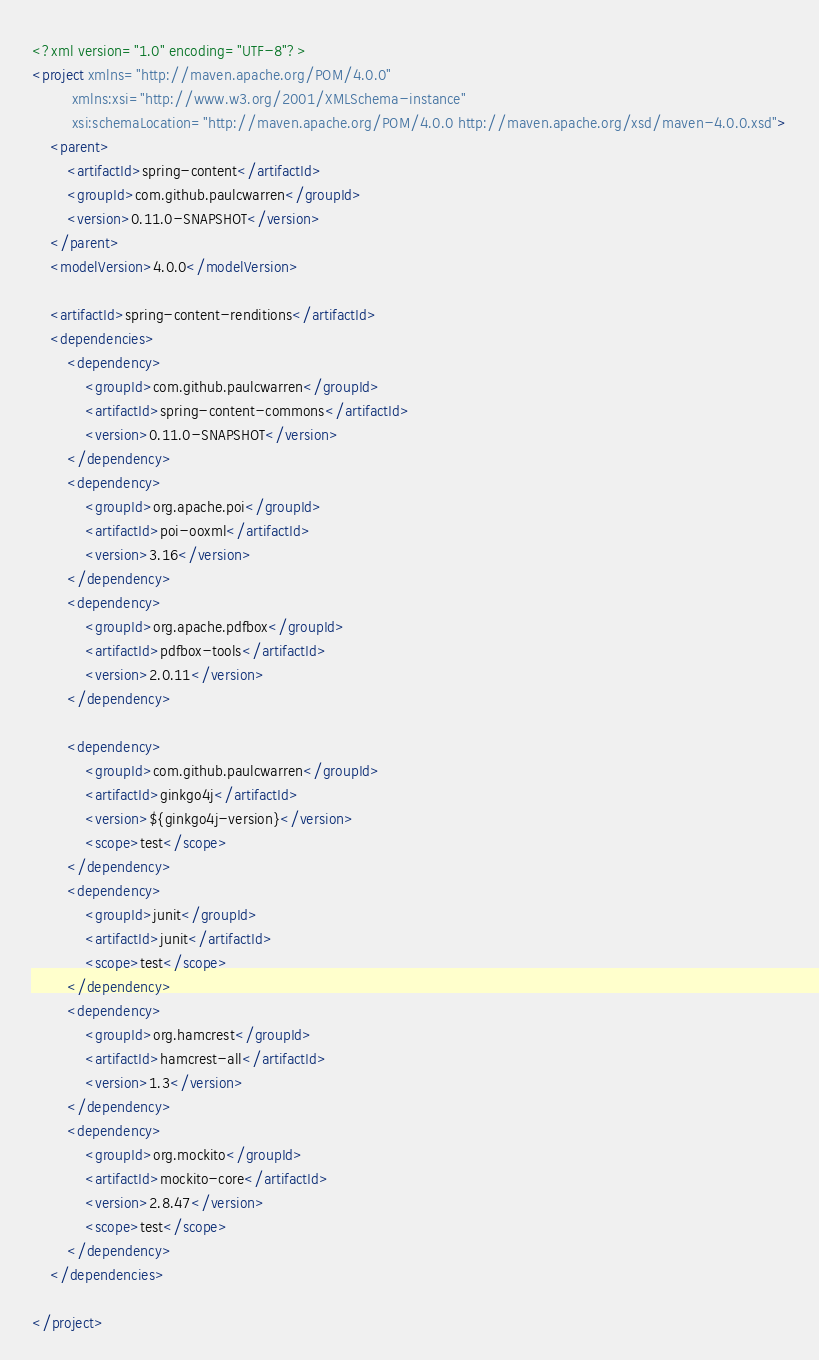Convert code to text. <code><loc_0><loc_0><loc_500><loc_500><_XML_><?xml version="1.0" encoding="UTF-8"?>
<project xmlns="http://maven.apache.org/POM/4.0.0"
         xmlns:xsi="http://www.w3.org/2001/XMLSchema-instance"
         xsi:schemaLocation="http://maven.apache.org/POM/4.0.0 http://maven.apache.org/xsd/maven-4.0.0.xsd">
    <parent>
        <artifactId>spring-content</artifactId>
        <groupId>com.github.paulcwarren</groupId>
        <version>0.11.0-SNAPSHOT</version>
    </parent>
    <modelVersion>4.0.0</modelVersion>

    <artifactId>spring-content-renditions</artifactId>
    <dependencies>
        <dependency>
            <groupId>com.github.paulcwarren</groupId>
            <artifactId>spring-content-commons</artifactId>
            <version>0.11.0-SNAPSHOT</version>
        </dependency>
        <dependency>
            <groupId>org.apache.poi</groupId>
            <artifactId>poi-ooxml</artifactId>
            <version>3.16</version>
        </dependency>
        <dependency>
            <groupId>org.apache.pdfbox</groupId>
            <artifactId>pdfbox-tools</artifactId>
            <version>2.0.11</version>
        </dependency>

        <dependency>
            <groupId>com.github.paulcwarren</groupId>
            <artifactId>ginkgo4j</artifactId>
            <version>${ginkgo4j-version}</version>
            <scope>test</scope>
        </dependency>
        <dependency>
            <groupId>junit</groupId>
            <artifactId>junit</artifactId>
            <scope>test</scope>
        </dependency>
        <dependency>
            <groupId>org.hamcrest</groupId>
            <artifactId>hamcrest-all</artifactId>
            <version>1.3</version>
        </dependency>
        <dependency>
            <groupId>org.mockito</groupId>
            <artifactId>mockito-core</artifactId>
            <version>2.8.47</version>
            <scope>test</scope>
        </dependency>
    </dependencies>

</project></code> 